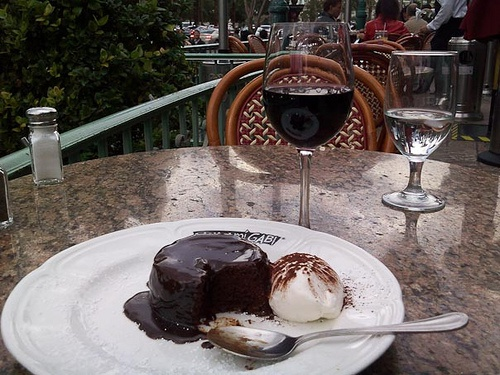Describe the objects in this image and their specific colors. I can see dining table in black, gray, darkgray, and maroon tones, chair in black, maroon, gray, and brown tones, wine glass in black, gray, maroon, and darkgray tones, cake in black, gray, and darkgray tones, and wine glass in black, gray, and darkgray tones in this image. 